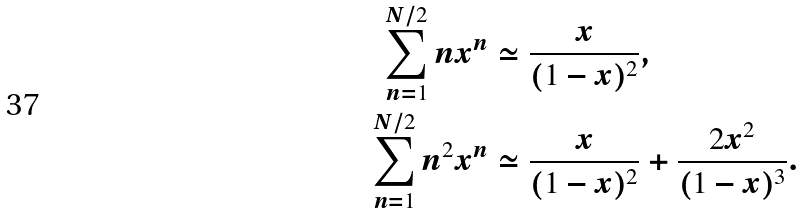Convert formula to latex. <formula><loc_0><loc_0><loc_500><loc_500>\sum _ { n = 1 } ^ { N / 2 } n x ^ { n } & \simeq \frac { x } { ( 1 - x ) ^ { 2 } } , \\ \sum _ { n = 1 } ^ { N / 2 } n ^ { 2 } x ^ { n } & \simeq \frac { x } { ( 1 - x ) ^ { 2 } } + \frac { 2 x ^ { 2 } } { ( 1 - x ) ^ { 3 } } .</formula> 